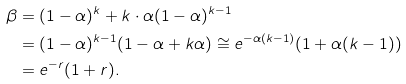Convert formula to latex. <formula><loc_0><loc_0><loc_500><loc_500>\beta & = ( 1 - \alpha ) ^ { k } + k \cdot \alpha ( 1 - \alpha ) ^ { k - 1 } \\ & = ( 1 - \alpha ) ^ { k - 1 } ( 1 - \alpha + k \alpha ) \cong e ^ { - \alpha ( k - 1 ) } ( 1 + \alpha ( k - 1 ) ) \\ & = e ^ { - r } ( 1 + r ) .</formula> 